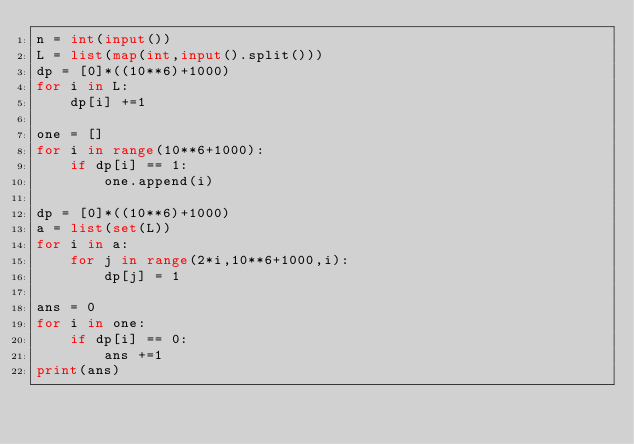<code> <loc_0><loc_0><loc_500><loc_500><_Python_>n = int(input())
L = list(map(int,input().split()))
dp = [0]*((10**6)+1000)
for i in L:
    dp[i] +=1

one = []
for i in range(10**6+1000):
    if dp[i] == 1:
        one.append(i)

dp = [0]*((10**6)+1000)
a = list(set(L))
for i in a:
    for j in range(2*i,10**6+1000,i):
        dp[j] = 1

ans = 0
for i in one:
    if dp[i] == 0:
        ans +=1
print(ans)
</code> 